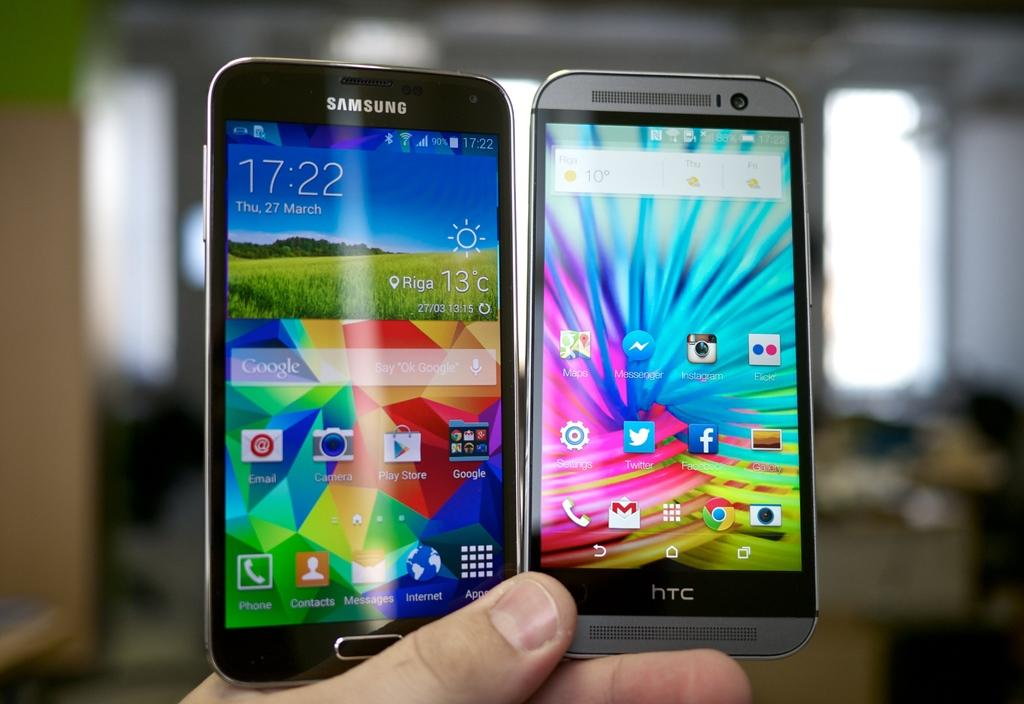<image>
Write a terse but informative summary of the picture. Someone is holding up a HTC device and a Samsung device, in the same hand, side by side. 